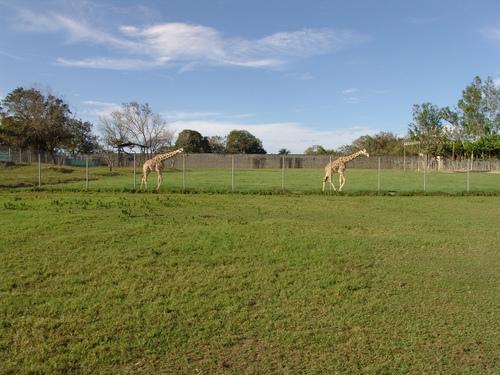What building is in the background?
Write a very short answer. 0. Overcast or sunny?
Write a very short answer. Sunny. Where do these giraffe live?
Be succinct. Zoo. What material is the fence made of?
Keep it brief. Metal. Do these giraffes have enough space?
Keep it brief. Yes. What noise do the animals in the field make?
Answer briefly. None. Are the giraffes in a zoo?
Write a very short answer. Yes. Are these cows?
Write a very short answer. No. Are the animals in the jungle?
Concise answer only. No. How many zebras are babies?
Short answer required. 0. What kind of animals are there?
Concise answer only. Giraffes. Is this animal in the wild?
Be succinct. No. How many species of animal are shown?
Quick response, please. 1. 